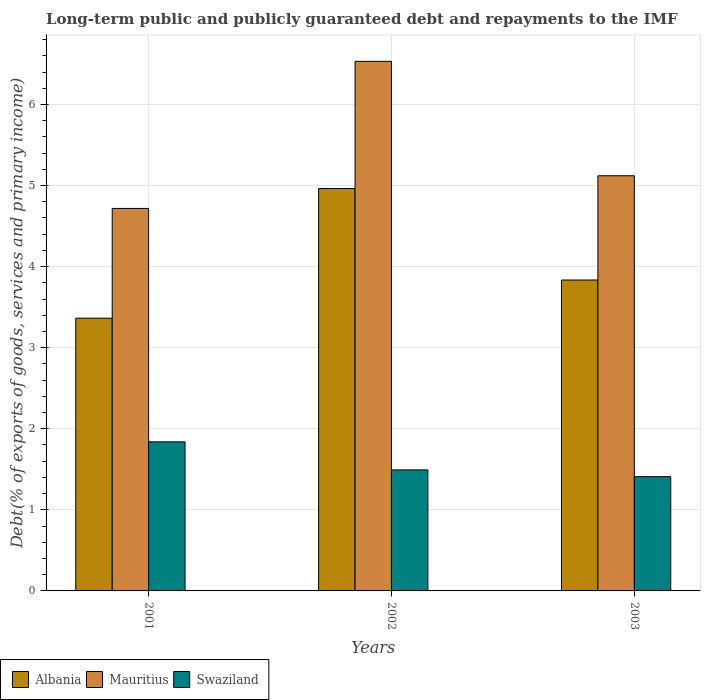What is the debt and repayments in Albania in 2001?
Offer a terse response. 3.36. Across all years, what is the maximum debt and repayments in Swaziland?
Keep it short and to the point. 1.84. Across all years, what is the minimum debt and repayments in Swaziland?
Your answer should be very brief. 1.41. In which year was the debt and repayments in Albania maximum?
Give a very brief answer. 2002. In which year was the debt and repayments in Mauritius minimum?
Give a very brief answer. 2001. What is the total debt and repayments in Albania in the graph?
Your answer should be very brief. 12.16. What is the difference between the debt and repayments in Swaziland in 2001 and that in 2003?
Provide a succinct answer. 0.43. What is the difference between the debt and repayments in Albania in 2003 and the debt and repayments in Mauritius in 2001?
Your answer should be very brief. -0.88. What is the average debt and repayments in Swaziland per year?
Provide a succinct answer. 1.58. In the year 2002, what is the difference between the debt and repayments in Mauritius and debt and repayments in Albania?
Your answer should be compact. 1.57. What is the ratio of the debt and repayments in Albania in 2001 to that in 2003?
Offer a terse response. 0.88. What is the difference between the highest and the second highest debt and repayments in Swaziland?
Keep it short and to the point. 0.35. What is the difference between the highest and the lowest debt and repayments in Swaziland?
Offer a terse response. 0.43. In how many years, is the debt and repayments in Albania greater than the average debt and repayments in Albania taken over all years?
Provide a short and direct response. 1. Is the sum of the debt and repayments in Mauritius in 2001 and 2002 greater than the maximum debt and repayments in Swaziland across all years?
Make the answer very short. Yes. What does the 3rd bar from the left in 2003 represents?
Provide a succinct answer. Swaziland. What does the 2nd bar from the right in 2001 represents?
Your answer should be very brief. Mauritius. Is it the case that in every year, the sum of the debt and repayments in Albania and debt and repayments in Swaziland is greater than the debt and repayments in Mauritius?
Keep it short and to the point. No. How many bars are there?
Your response must be concise. 9. How many years are there in the graph?
Offer a terse response. 3. Are the values on the major ticks of Y-axis written in scientific E-notation?
Your answer should be very brief. No. Does the graph contain any zero values?
Offer a terse response. No. Does the graph contain grids?
Offer a terse response. Yes. Where does the legend appear in the graph?
Ensure brevity in your answer.  Bottom left. What is the title of the graph?
Your answer should be very brief. Long-term public and publicly guaranteed debt and repayments to the IMF. Does "Europe(developing only)" appear as one of the legend labels in the graph?
Offer a terse response. No. What is the label or title of the Y-axis?
Make the answer very short. Debt(% of exports of goods, services and primary income). What is the Debt(% of exports of goods, services and primary income) in Albania in 2001?
Your answer should be very brief. 3.36. What is the Debt(% of exports of goods, services and primary income) in Mauritius in 2001?
Offer a very short reply. 4.72. What is the Debt(% of exports of goods, services and primary income) in Swaziland in 2001?
Offer a terse response. 1.84. What is the Debt(% of exports of goods, services and primary income) of Albania in 2002?
Your answer should be very brief. 4.96. What is the Debt(% of exports of goods, services and primary income) in Mauritius in 2002?
Make the answer very short. 6.53. What is the Debt(% of exports of goods, services and primary income) of Swaziland in 2002?
Provide a succinct answer. 1.49. What is the Debt(% of exports of goods, services and primary income) in Albania in 2003?
Give a very brief answer. 3.83. What is the Debt(% of exports of goods, services and primary income) in Mauritius in 2003?
Offer a very short reply. 5.12. What is the Debt(% of exports of goods, services and primary income) of Swaziland in 2003?
Your answer should be very brief. 1.41. Across all years, what is the maximum Debt(% of exports of goods, services and primary income) in Albania?
Ensure brevity in your answer.  4.96. Across all years, what is the maximum Debt(% of exports of goods, services and primary income) in Mauritius?
Give a very brief answer. 6.53. Across all years, what is the maximum Debt(% of exports of goods, services and primary income) of Swaziland?
Make the answer very short. 1.84. Across all years, what is the minimum Debt(% of exports of goods, services and primary income) in Albania?
Make the answer very short. 3.36. Across all years, what is the minimum Debt(% of exports of goods, services and primary income) in Mauritius?
Provide a succinct answer. 4.72. Across all years, what is the minimum Debt(% of exports of goods, services and primary income) in Swaziland?
Your answer should be very brief. 1.41. What is the total Debt(% of exports of goods, services and primary income) of Albania in the graph?
Your response must be concise. 12.16. What is the total Debt(% of exports of goods, services and primary income) in Mauritius in the graph?
Ensure brevity in your answer.  16.37. What is the total Debt(% of exports of goods, services and primary income) in Swaziland in the graph?
Give a very brief answer. 4.74. What is the difference between the Debt(% of exports of goods, services and primary income) of Albania in 2001 and that in 2002?
Keep it short and to the point. -1.6. What is the difference between the Debt(% of exports of goods, services and primary income) of Mauritius in 2001 and that in 2002?
Your response must be concise. -1.81. What is the difference between the Debt(% of exports of goods, services and primary income) of Swaziland in 2001 and that in 2002?
Your response must be concise. 0.35. What is the difference between the Debt(% of exports of goods, services and primary income) in Albania in 2001 and that in 2003?
Provide a succinct answer. -0.47. What is the difference between the Debt(% of exports of goods, services and primary income) in Mauritius in 2001 and that in 2003?
Give a very brief answer. -0.4. What is the difference between the Debt(% of exports of goods, services and primary income) of Swaziland in 2001 and that in 2003?
Give a very brief answer. 0.43. What is the difference between the Debt(% of exports of goods, services and primary income) in Albania in 2002 and that in 2003?
Make the answer very short. 1.13. What is the difference between the Debt(% of exports of goods, services and primary income) in Mauritius in 2002 and that in 2003?
Make the answer very short. 1.41. What is the difference between the Debt(% of exports of goods, services and primary income) of Swaziland in 2002 and that in 2003?
Ensure brevity in your answer.  0.08. What is the difference between the Debt(% of exports of goods, services and primary income) in Albania in 2001 and the Debt(% of exports of goods, services and primary income) in Mauritius in 2002?
Provide a short and direct response. -3.17. What is the difference between the Debt(% of exports of goods, services and primary income) of Albania in 2001 and the Debt(% of exports of goods, services and primary income) of Swaziland in 2002?
Offer a terse response. 1.87. What is the difference between the Debt(% of exports of goods, services and primary income) of Mauritius in 2001 and the Debt(% of exports of goods, services and primary income) of Swaziland in 2002?
Keep it short and to the point. 3.22. What is the difference between the Debt(% of exports of goods, services and primary income) in Albania in 2001 and the Debt(% of exports of goods, services and primary income) in Mauritius in 2003?
Your answer should be compact. -1.76. What is the difference between the Debt(% of exports of goods, services and primary income) of Albania in 2001 and the Debt(% of exports of goods, services and primary income) of Swaziland in 2003?
Offer a terse response. 1.95. What is the difference between the Debt(% of exports of goods, services and primary income) in Mauritius in 2001 and the Debt(% of exports of goods, services and primary income) in Swaziland in 2003?
Offer a very short reply. 3.31. What is the difference between the Debt(% of exports of goods, services and primary income) in Albania in 2002 and the Debt(% of exports of goods, services and primary income) in Mauritius in 2003?
Make the answer very short. -0.16. What is the difference between the Debt(% of exports of goods, services and primary income) in Albania in 2002 and the Debt(% of exports of goods, services and primary income) in Swaziland in 2003?
Your response must be concise. 3.55. What is the difference between the Debt(% of exports of goods, services and primary income) of Mauritius in 2002 and the Debt(% of exports of goods, services and primary income) of Swaziland in 2003?
Give a very brief answer. 5.12. What is the average Debt(% of exports of goods, services and primary income) of Albania per year?
Ensure brevity in your answer.  4.05. What is the average Debt(% of exports of goods, services and primary income) in Mauritius per year?
Ensure brevity in your answer.  5.46. What is the average Debt(% of exports of goods, services and primary income) in Swaziland per year?
Give a very brief answer. 1.58. In the year 2001, what is the difference between the Debt(% of exports of goods, services and primary income) of Albania and Debt(% of exports of goods, services and primary income) of Mauritius?
Your response must be concise. -1.35. In the year 2001, what is the difference between the Debt(% of exports of goods, services and primary income) of Albania and Debt(% of exports of goods, services and primary income) of Swaziland?
Your answer should be very brief. 1.53. In the year 2001, what is the difference between the Debt(% of exports of goods, services and primary income) of Mauritius and Debt(% of exports of goods, services and primary income) of Swaziland?
Your response must be concise. 2.88. In the year 2002, what is the difference between the Debt(% of exports of goods, services and primary income) of Albania and Debt(% of exports of goods, services and primary income) of Mauritius?
Offer a very short reply. -1.57. In the year 2002, what is the difference between the Debt(% of exports of goods, services and primary income) in Albania and Debt(% of exports of goods, services and primary income) in Swaziland?
Give a very brief answer. 3.47. In the year 2002, what is the difference between the Debt(% of exports of goods, services and primary income) in Mauritius and Debt(% of exports of goods, services and primary income) in Swaziland?
Your response must be concise. 5.04. In the year 2003, what is the difference between the Debt(% of exports of goods, services and primary income) in Albania and Debt(% of exports of goods, services and primary income) in Mauritius?
Your answer should be compact. -1.29. In the year 2003, what is the difference between the Debt(% of exports of goods, services and primary income) of Albania and Debt(% of exports of goods, services and primary income) of Swaziland?
Make the answer very short. 2.43. In the year 2003, what is the difference between the Debt(% of exports of goods, services and primary income) in Mauritius and Debt(% of exports of goods, services and primary income) in Swaziland?
Offer a terse response. 3.71. What is the ratio of the Debt(% of exports of goods, services and primary income) in Albania in 2001 to that in 2002?
Ensure brevity in your answer.  0.68. What is the ratio of the Debt(% of exports of goods, services and primary income) of Mauritius in 2001 to that in 2002?
Keep it short and to the point. 0.72. What is the ratio of the Debt(% of exports of goods, services and primary income) in Swaziland in 2001 to that in 2002?
Offer a very short reply. 1.23. What is the ratio of the Debt(% of exports of goods, services and primary income) of Albania in 2001 to that in 2003?
Your answer should be very brief. 0.88. What is the ratio of the Debt(% of exports of goods, services and primary income) of Mauritius in 2001 to that in 2003?
Your response must be concise. 0.92. What is the ratio of the Debt(% of exports of goods, services and primary income) in Swaziland in 2001 to that in 2003?
Keep it short and to the point. 1.3. What is the ratio of the Debt(% of exports of goods, services and primary income) in Albania in 2002 to that in 2003?
Provide a short and direct response. 1.29. What is the ratio of the Debt(% of exports of goods, services and primary income) in Mauritius in 2002 to that in 2003?
Provide a succinct answer. 1.28. What is the ratio of the Debt(% of exports of goods, services and primary income) of Swaziland in 2002 to that in 2003?
Provide a succinct answer. 1.06. What is the difference between the highest and the second highest Debt(% of exports of goods, services and primary income) of Albania?
Make the answer very short. 1.13. What is the difference between the highest and the second highest Debt(% of exports of goods, services and primary income) in Mauritius?
Give a very brief answer. 1.41. What is the difference between the highest and the second highest Debt(% of exports of goods, services and primary income) of Swaziland?
Provide a short and direct response. 0.35. What is the difference between the highest and the lowest Debt(% of exports of goods, services and primary income) of Albania?
Keep it short and to the point. 1.6. What is the difference between the highest and the lowest Debt(% of exports of goods, services and primary income) of Mauritius?
Your response must be concise. 1.81. What is the difference between the highest and the lowest Debt(% of exports of goods, services and primary income) of Swaziland?
Keep it short and to the point. 0.43. 